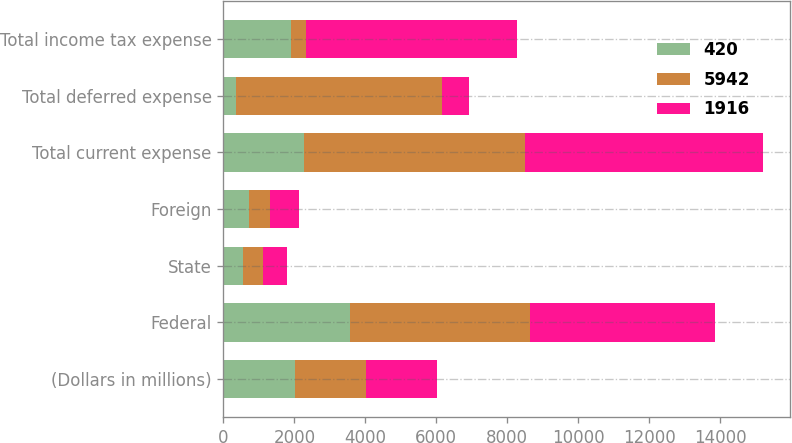Convert chart to OTSL. <chart><loc_0><loc_0><loc_500><loc_500><stacked_bar_chart><ecel><fcel>(Dollars in millions)<fcel>Federal<fcel>State<fcel>Foreign<fcel>Total current expense<fcel>Total deferred expense<fcel>Total income tax expense<nl><fcel>420<fcel>2009<fcel>3576<fcel>555<fcel>735<fcel>2286<fcel>370<fcel>1916<nl><fcel>5942<fcel>2008<fcel>5075<fcel>561<fcel>585<fcel>6221<fcel>5801<fcel>420<nl><fcel>1916<fcel>2007<fcel>5210<fcel>681<fcel>804<fcel>6695<fcel>753<fcel>5942<nl></chart> 